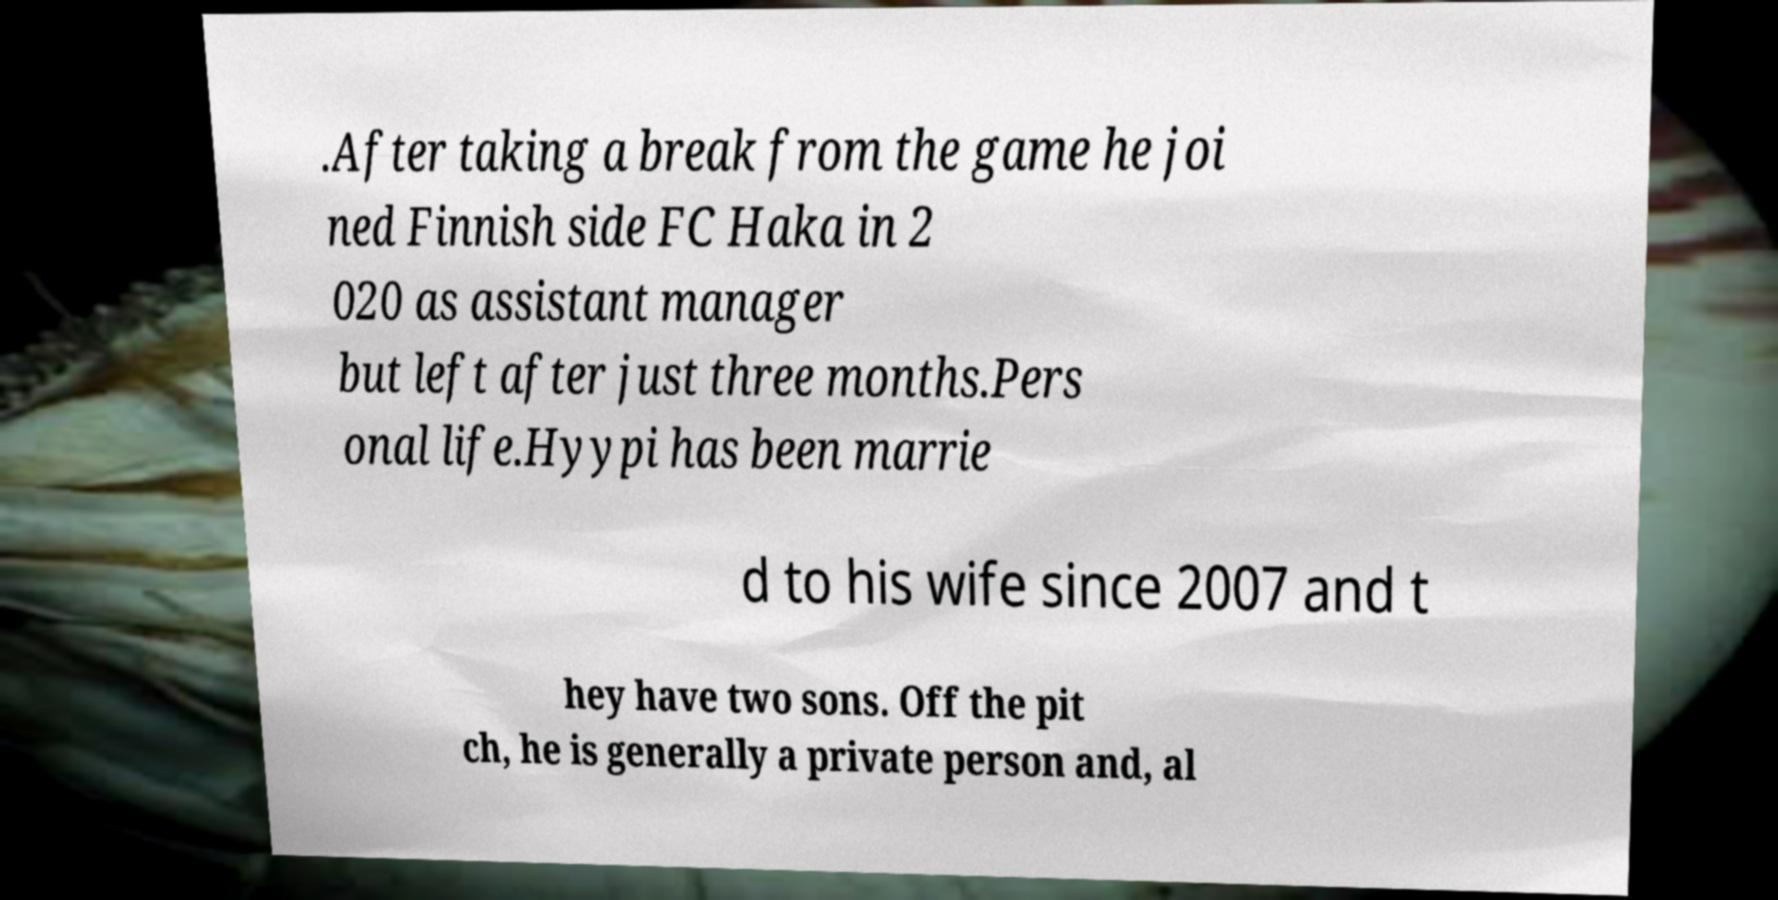Please identify and transcribe the text found in this image. .After taking a break from the game he joi ned Finnish side FC Haka in 2 020 as assistant manager but left after just three months.Pers onal life.Hyypi has been marrie d to his wife since 2007 and t hey have two sons. Off the pit ch, he is generally a private person and, al 